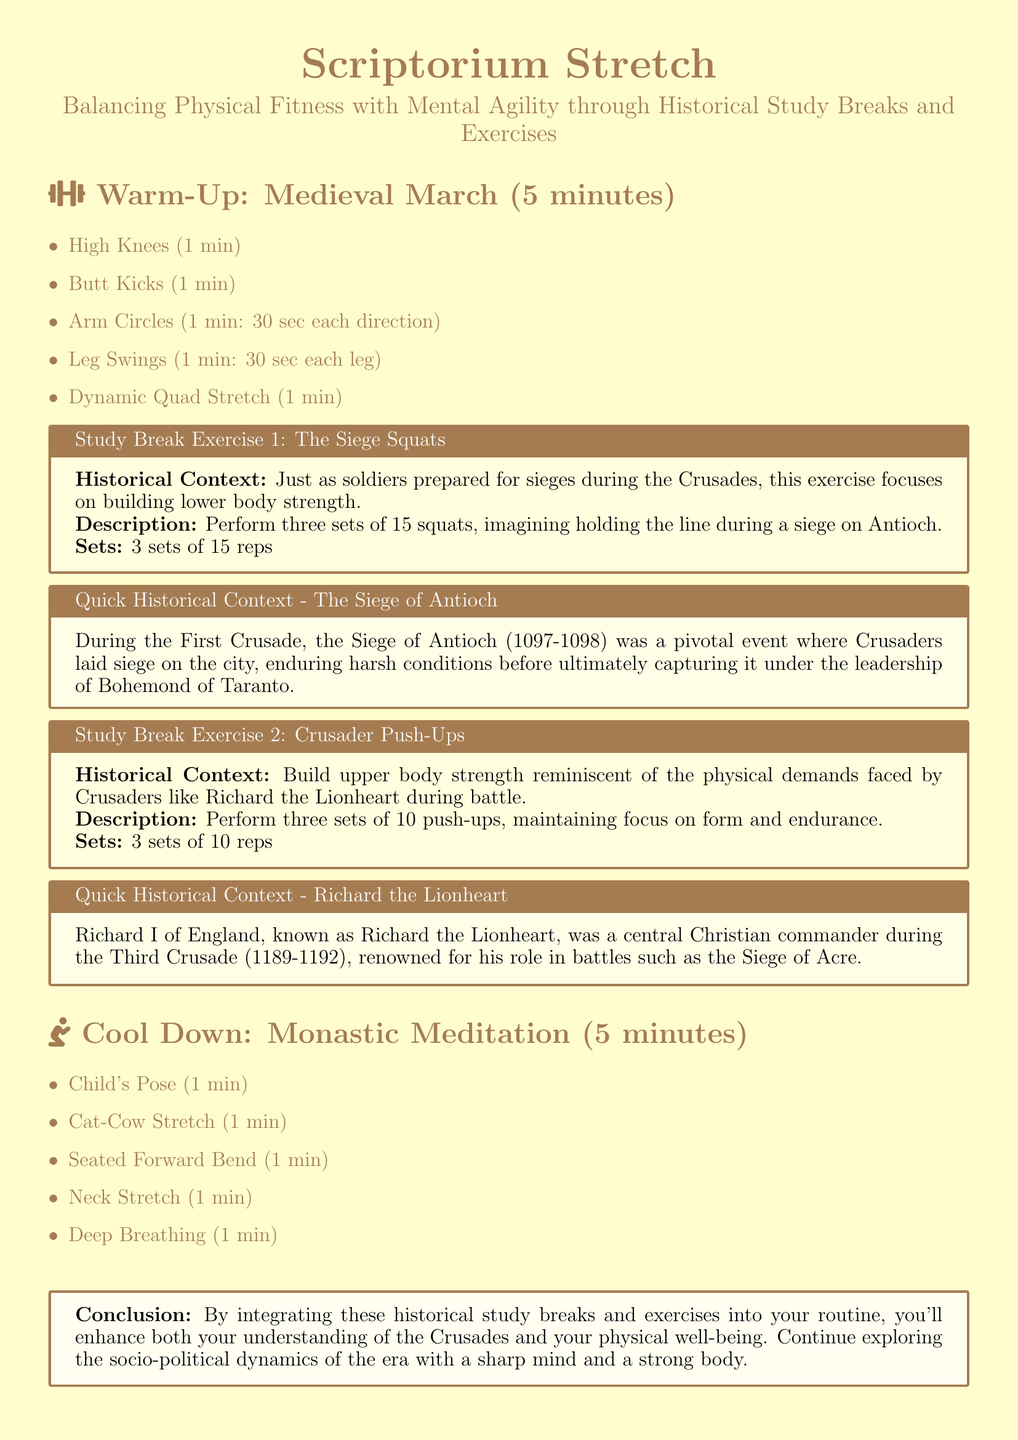What is the duration of the warm-up exercise? The duration of the warm-up exercise is stated as 5 minutes.
Answer: 5 minutes How many sets of squats are performed in the first study break exercise? The document specifies that three sets of 15 squats should be performed.
Answer: 3 sets of 15 reps What historical event is associated with the Siege Squats exercise? The exercise relates to the Siege of Antioch during the First Crusade.
Answer: Siege of Antioch Who is known as Richard the Lionheart in the context of the Crusades? The document describes Richard I of England as Richard the Lionheart, a central Christian commander.
Answer: Richard I of England What is the focus of the exercise "Crusader Push-Ups"? The focus is on building upper body strength reminiscent of the physical demands faced by Crusaders.
Answer: Upper body strength What is the total number of exercises listed in the document? The document identifies four exercises: one warm-up, two study break exercises, and one cool down.
Answer: Four exercises What type of stretch is included in the cool down? The cool down includes Child's Pose as one of the stretches.
Answer: Child's Pose What is the purpose of integrating historical study breaks and exercises according to the conclusion? The conclusion indicates that integrating these helps enhance both understanding of the Crusades and physical well-being.
Answer: Understanding of the Crusades and physical well-being 